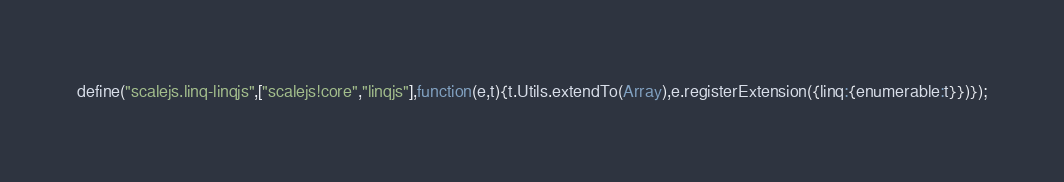Convert code to text. <code><loc_0><loc_0><loc_500><loc_500><_JavaScript_>define("scalejs.linq-linqjs",["scalejs!core","linqjs"],function(e,t){t.Utils.extendTo(Array),e.registerExtension({linq:{enumerable:t}})});</code> 